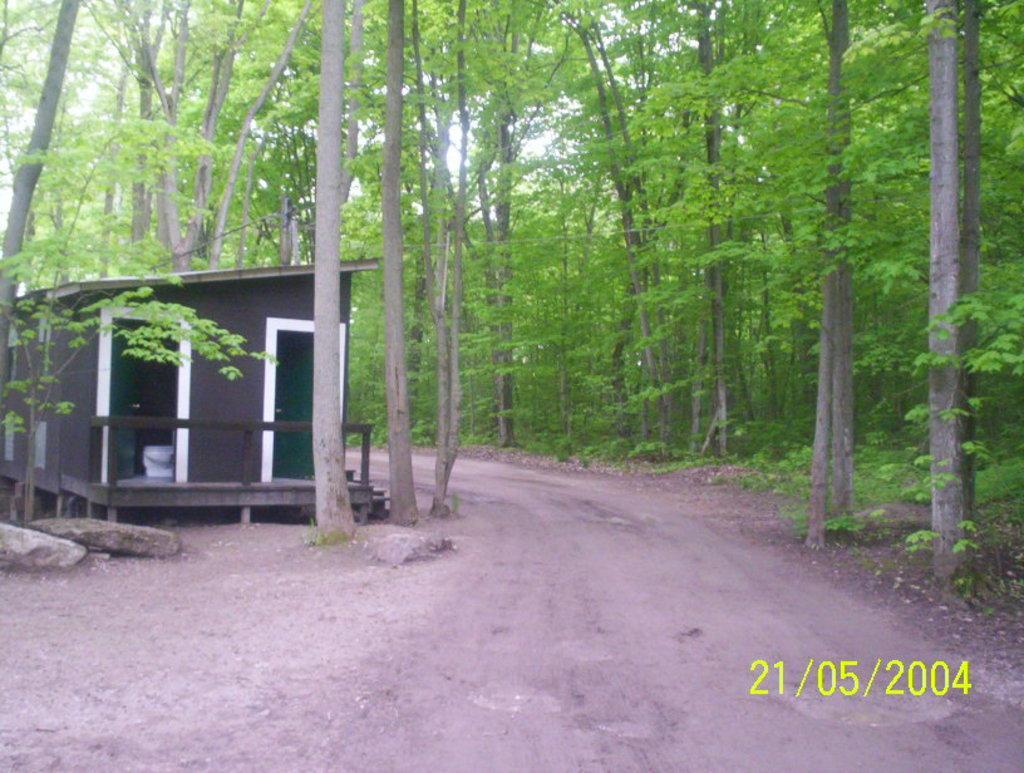In one or two sentences, can you explain what this image depicts? In this image we can see a house with roof and doors. We can also see some stones, a pathway, a group of trees, the bark of the trees and the sky which looks cloudy. 